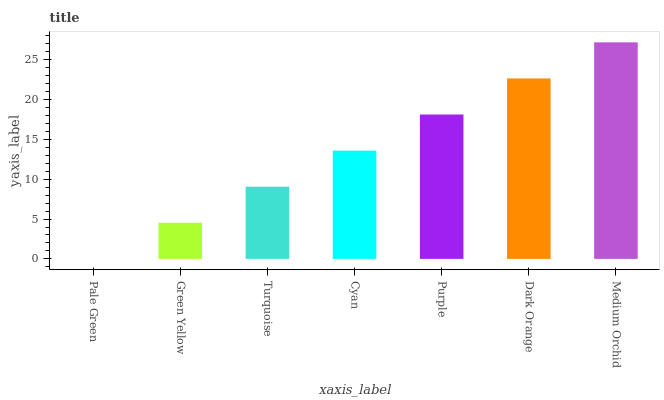Is Pale Green the minimum?
Answer yes or no. Yes. Is Medium Orchid the maximum?
Answer yes or no. Yes. Is Green Yellow the minimum?
Answer yes or no. No. Is Green Yellow the maximum?
Answer yes or no. No. Is Green Yellow greater than Pale Green?
Answer yes or no. Yes. Is Pale Green less than Green Yellow?
Answer yes or no. Yes. Is Pale Green greater than Green Yellow?
Answer yes or no. No. Is Green Yellow less than Pale Green?
Answer yes or no. No. Is Cyan the high median?
Answer yes or no. Yes. Is Cyan the low median?
Answer yes or no. Yes. Is Green Yellow the high median?
Answer yes or no. No. Is Purple the low median?
Answer yes or no. No. 